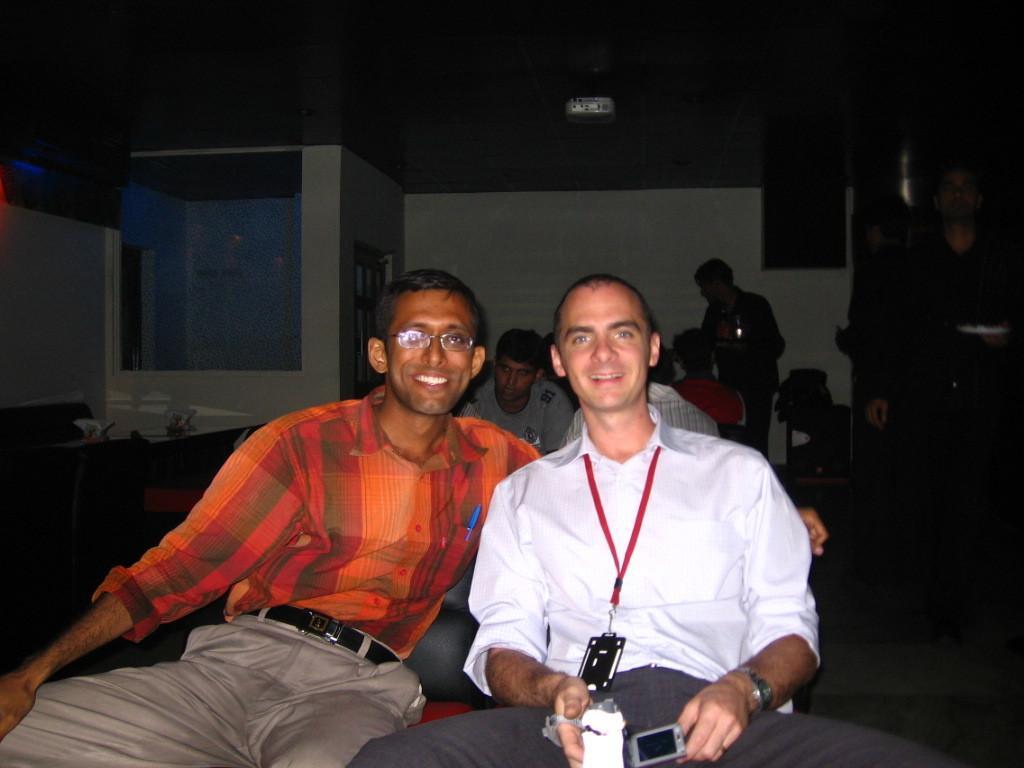Describe this image in one or two sentences. In this picture there are two men sitting in the chair smiling and giving a pose to the camera. Behind there is a dark background and wall. 